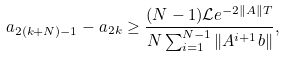Convert formula to latex. <formula><loc_0><loc_0><loc_500><loc_500>a _ { 2 ( k + N ) - 1 } - a _ { 2 k } \geq \frac { ( N - 1 ) \mathcal { L } e ^ { - 2 \| A \| T } } { N \sum _ { i = 1 } ^ { N - 1 } \| A ^ { i + 1 } b \| } ,</formula> 